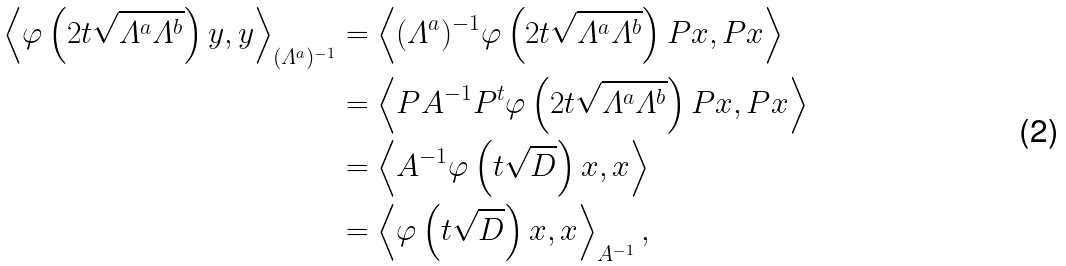<formula> <loc_0><loc_0><loc_500><loc_500>\left \langle \varphi \left ( 2 t \sqrt { \varLambda ^ { a } \varLambda ^ { b } } \right ) y , y \right \rangle _ { ( \varLambda ^ { a } ) ^ { - 1 } } & = \left \langle ( \varLambda ^ { a } ) ^ { - 1 } \varphi \left ( 2 t \sqrt { \varLambda ^ { a } \varLambda ^ { b } } \right ) P x , P x \right \rangle \\ & = \left \langle P A ^ { - 1 } P ^ { t } \varphi \left ( 2 t \sqrt { \varLambda ^ { a } \varLambda ^ { b } } \right ) P x , P x \right \rangle \\ & = \left \langle A ^ { - 1 } \varphi \left ( t \sqrt { D } \right ) x , x \right \rangle \\ & = \left \langle \varphi \left ( t \sqrt { D } \right ) x , x \right \rangle _ { A ^ { - 1 } } ,</formula> 